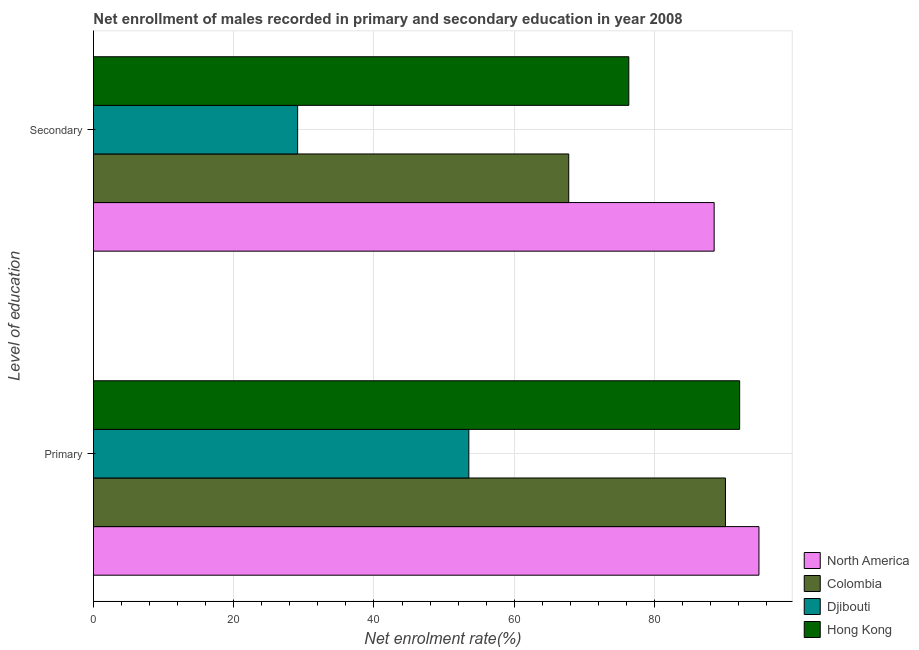How many groups of bars are there?
Provide a short and direct response. 2. Are the number of bars per tick equal to the number of legend labels?
Make the answer very short. Yes. What is the label of the 1st group of bars from the top?
Provide a succinct answer. Secondary. What is the enrollment rate in primary education in Djibouti?
Your answer should be very brief. 53.53. Across all countries, what is the maximum enrollment rate in secondary education?
Your answer should be very brief. 88.51. Across all countries, what is the minimum enrollment rate in secondary education?
Your response must be concise. 29.11. In which country was the enrollment rate in secondary education minimum?
Offer a very short reply. Djibouti. What is the total enrollment rate in secondary education in the graph?
Your response must be concise. 261.73. What is the difference between the enrollment rate in primary education in North America and that in Djibouti?
Ensure brevity in your answer.  41.37. What is the difference between the enrollment rate in secondary education in North America and the enrollment rate in primary education in Hong Kong?
Ensure brevity in your answer.  -3.64. What is the average enrollment rate in primary education per country?
Provide a succinct answer. 82.67. What is the difference between the enrollment rate in secondary education and enrollment rate in primary education in North America?
Provide a succinct answer. -6.39. In how many countries, is the enrollment rate in secondary education greater than 36 %?
Your answer should be compact. 3. What is the ratio of the enrollment rate in secondary education in Colombia to that in Djibouti?
Make the answer very short. 2.33. Is the enrollment rate in primary education in North America less than that in Djibouti?
Your response must be concise. No. In how many countries, is the enrollment rate in secondary education greater than the average enrollment rate in secondary education taken over all countries?
Your response must be concise. 3. What does the 2nd bar from the top in Secondary represents?
Make the answer very short. Djibouti. What does the 3rd bar from the bottom in Secondary represents?
Your answer should be very brief. Djibouti. How many bars are there?
Offer a terse response. 8. How many countries are there in the graph?
Your answer should be very brief. 4. Does the graph contain any zero values?
Your answer should be compact. No. How many legend labels are there?
Keep it short and to the point. 4. What is the title of the graph?
Make the answer very short. Net enrollment of males recorded in primary and secondary education in year 2008. Does "Latin America(developing only)" appear as one of the legend labels in the graph?
Keep it short and to the point. No. What is the label or title of the X-axis?
Your response must be concise. Net enrolment rate(%). What is the label or title of the Y-axis?
Offer a terse response. Level of education. What is the Net enrolment rate(%) in North America in Primary?
Make the answer very short. 94.9. What is the Net enrolment rate(%) of Colombia in Primary?
Keep it short and to the point. 90.12. What is the Net enrolment rate(%) in Djibouti in Primary?
Offer a terse response. 53.53. What is the Net enrolment rate(%) of Hong Kong in Primary?
Provide a short and direct response. 92.14. What is the Net enrolment rate(%) of North America in Secondary?
Your answer should be very brief. 88.51. What is the Net enrolment rate(%) of Colombia in Secondary?
Make the answer very short. 67.77. What is the Net enrolment rate(%) of Djibouti in Secondary?
Give a very brief answer. 29.11. What is the Net enrolment rate(%) of Hong Kong in Secondary?
Provide a short and direct response. 76.34. Across all Level of education, what is the maximum Net enrolment rate(%) of North America?
Your answer should be very brief. 94.9. Across all Level of education, what is the maximum Net enrolment rate(%) of Colombia?
Offer a terse response. 90.12. Across all Level of education, what is the maximum Net enrolment rate(%) of Djibouti?
Keep it short and to the point. 53.53. Across all Level of education, what is the maximum Net enrolment rate(%) of Hong Kong?
Keep it short and to the point. 92.14. Across all Level of education, what is the minimum Net enrolment rate(%) of North America?
Your answer should be compact. 88.51. Across all Level of education, what is the minimum Net enrolment rate(%) in Colombia?
Your response must be concise. 67.77. Across all Level of education, what is the minimum Net enrolment rate(%) of Djibouti?
Offer a very short reply. 29.11. Across all Level of education, what is the minimum Net enrolment rate(%) of Hong Kong?
Give a very brief answer. 76.34. What is the total Net enrolment rate(%) in North America in the graph?
Keep it short and to the point. 183.41. What is the total Net enrolment rate(%) in Colombia in the graph?
Your answer should be very brief. 157.89. What is the total Net enrolment rate(%) in Djibouti in the graph?
Provide a short and direct response. 82.64. What is the total Net enrolment rate(%) in Hong Kong in the graph?
Provide a short and direct response. 168.48. What is the difference between the Net enrolment rate(%) in North America in Primary and that in Secondary?
Ensure brevity in your answer.  6.39. What is the difference between the Net enrolment rate(%) in Colombia in Primary and that in Secondary?
Offer a very short reply. 22.35. What is the difference between the Net enrolment rate(%) in Djibouti in Primary and that in Secondary?
Your response must be concise. 24.41. What is the difference between the Net enrolment rate(%) in Hong Kong in Primary and that in Secondary?
Provide a short and direct response. 15.81. What is the difference between the Net enrolment rate(%) in North America in Primary and the Net enrolment rate(%) in Colombia in Secondary?
Your response must be concise. 27.13. What is the difference between the Net enrolment rate(%) of North America in Primary and the Net enrolment rate(%) of Djibouti in Secondary?
Provide a succinct answer. 65.78. What is the difference between the Net enrolment rate(%) in North America in Primary and the Net enrolment rate(%) in Hong Kong in Secondary?
Your response must be concise. 18.56. What is the difference between the Net enrolment rate(%) of Colombia in Primary and the Net enrolment rate(%) of Djibouti in Secondary?
Make the answer very short. 61.01. What is the difference between the Net enrolment rate(%) in Colombia in Primary and the Net enrolment rate(%) in Hong Kong in Secondary?
Offer a terse response. 13.78. What is the difference between the Net enrolment rate(%) of Djibouti in Primary and the Net enrolment rate(%) of Hong Kong in Secondary?
Offer a terse response. -22.81. What is the average Net enrolment rate(%) of North America per Level of education?
Your response must be concise. 91.7. What is the average Net enrolment rate(%) of Colombia per Level of education?
Your answer should be very brief. 78.95. What is the average Net enrolment rate(%) of Djibouti per Level of education?
Give a very brief answer. 41.32. What is the average Net enrolment rate(%) of Hong Kong per Level of education?
Give a very brief answer. 84.24. What is the difference between the Net enrolment rate(%) of North America and Net enrolment rate(%) of Colombia in Primary?
Keep it short and to the point. 4.78. What is the difference between the Net enrolment rate(%) of North America and Net enrolment rate(%) of Djibouti in Primary?
Your response must be concise. 41.37. What is the difference between the Net enrolment rate(%) in North America and Net enrolment rate(%) in Hong Kong in Primary?
Your answer should be very brief. 2.75. What is the difference between the Net enrolment rate(%) of Colombia and Net enrolment rate(%) of Djibouti in Primary?
Offer a very short reply. 36.59. What is the difference between the Net enrolment rate(%) in Colombia and Net enrolment rate(%) in Hong Kong in Primary?
Your answer should be compact. -2.02. What is the difference between the Net enrolment rate(%) in Djibouti and Net enrolment rate(%) in Hong Kong in Primary?
Offer a terse response. -38.62. What is the difference between the Net enrolment rate(%) of North America and Net enrolment rate(%) of Colombia in Secondary?
Make the answer very short. 20.74. What is the difference between the Net enrolment rate(%) of North America and Net enrolment rate(%) of Djibouti in Secondary?
Ensure brevity in your answer.  59.4. What is the difference between the Net enrolment rate(%) in North America and Net enrolment rate(%) in Hong Kong in Secondary?
Keep it short and to the point. 12.17. What is the difference between the Net enrolment rate(%) in Colombia and Net enrolment rate(%) in Djibouti in Secondary?
Offer a terse response. 38.66. What is the difference between the Net enrolment rate(%) of Colombia and Net enrolment rate(%) of Hong Kong in Secondary?
Provide a short and direct response. -8.57. What is the difference between the Net enrolment rate(%) of Djibouti and Net enrolment rate(%) of Hong Kong in Secondary?
Provide a succinct answer. -47.22. What is the ratio of the Net enrolment rate(%) in North America in Primary to that in Secondary?
Offer a terse response. 1.07. What is the ratio of the Net enrolment rate(%) in Colombia in Primary to that in Secondary?
Offer a terse response. 1.33. What is the ratio of the Net enrolment rate(%) of Djibouti in Primary to that in Secondary?
Your response must be concise. 1.84. What is the ratio of the Net enrolment rate(%) of Hong Kong in Primary to that in Secondary?
Offer a very short reply. 1.21. What is the difference between the highest and the second highest Net enrolment rate(%) in North America?
Your answer should be compact. 6.39. What is the difference between the highest and the second highest Net enrolment rate(%) of Colombia?
Keep it short and to the point. 22.35. What is the difference between the highest and the second highest Net enrolment rate(%) of Djibouti?
Give a very brief answer. 24.41. What is the difference between the highest and the second highest Net enrolment rate(%) of Hong Kong?
Keep it short and to the point. 15.81. What is the difference between the highest and the lowest Net enrolment rate(%) of North America?
Make the answer very short. 6.39. What is the difference between the highest and the lowest Net enrolment rate(%) of Colombia?
Make the answer very short. 22.35. What is the difference between the highest and the lowest Net enrolment rate(%) of Djibouti?
Give a very brief answer. 24.41. What is the difference between the highest and the lowest Net enrolment rate(%) in Hong Kong?
Your response must be concise. 15.81. 